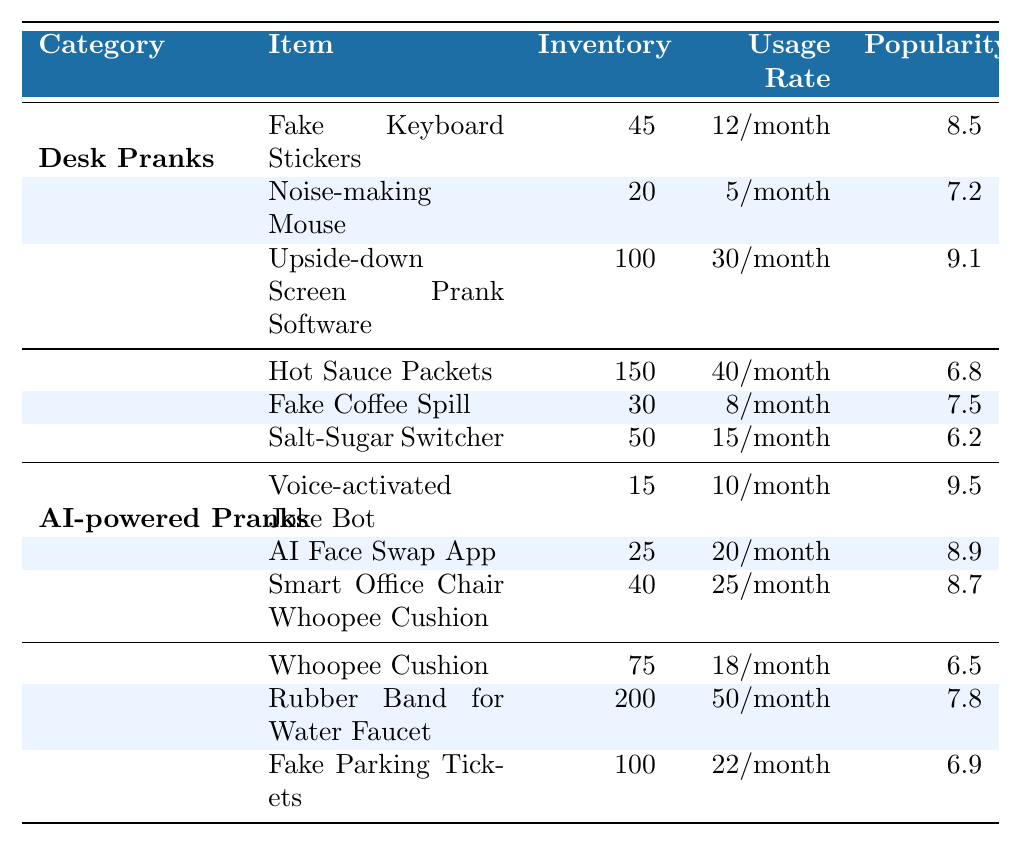What is the inventory of Fake Coffee Spill? According to the table, the inventory level for Fake Coffee Spill is clearly listed and shows as 30.
Answer: 30 Which item has the highest popularity within the Desk Pranks category? The table indicates the popularity ratings for items in the Desk Pranks category. The highest value noted is for Upside-down Screen Prank Software at 9.1.
Answer: Upside-down Screen Prank Software What is the total inventory for all AI-powered Pranks? The inventory levels for AI-powered Pranks are 15, 25, and 40 respectively. To get the total, sum them: 15 + 25 + 40 = 80.
Answer: 80 Is the usage rate for the Rubber Band for Water Faucet higher than that for Fake Parking Tickets? Looking at the table, Rubber Band for Water Faucet has a usage rate of 50/month, while Fake Parking Tickets has 22/month. Since 50 is greater than 22, the answer is true.
Answer: Yes What is the average popularity of Food-related Pranks? There are three items under Food-related Pranks with popularity ratings of 6.8, 7.5, and 6.2. To calculate the average: (6.8 + 7.5 + 6.2) = 20.5, then divide by 3: 20.5 / 3 = 6.83.
Answer: 6.83 Which category has the smallest inventory item? In the table, the smallest inventory item is the Voice-activated Joke Bot with an inventory of 15 among the listed items.
Answer: AI-powered Pranks If the usage rates for Fake Keyboard Stickers and Noise-making Mouse are combined, what is the total usage rate per month? The usage rate for Fake Keyboard Stickers is 12/month and for Noise-making Mouse it is 5/month. Adding them together gives a total of 12 + 5 = 17/month.
Answer: 17/month What item in the Classic Pranks category has the lowest popularity? By assessing the popularity of the three Classic Pranks, Whoopee Cushion has the lowest score of 6.5 compared to the others.
Answer: Whoopee Cushion How many more Hot Sauce Packets are there compared to Fake Coffee Spill? The inventory for Hot Sauce Packets is 150 and for Fake Coffee Spill is 30. The difference is calculated as 150 - 30 = 120.
Answer: 120 Which category contains the most items? Upon reviewing the table structure, all categories contain three items each, so none is greater than the others in number.
Answer: All categories have the same number of items 